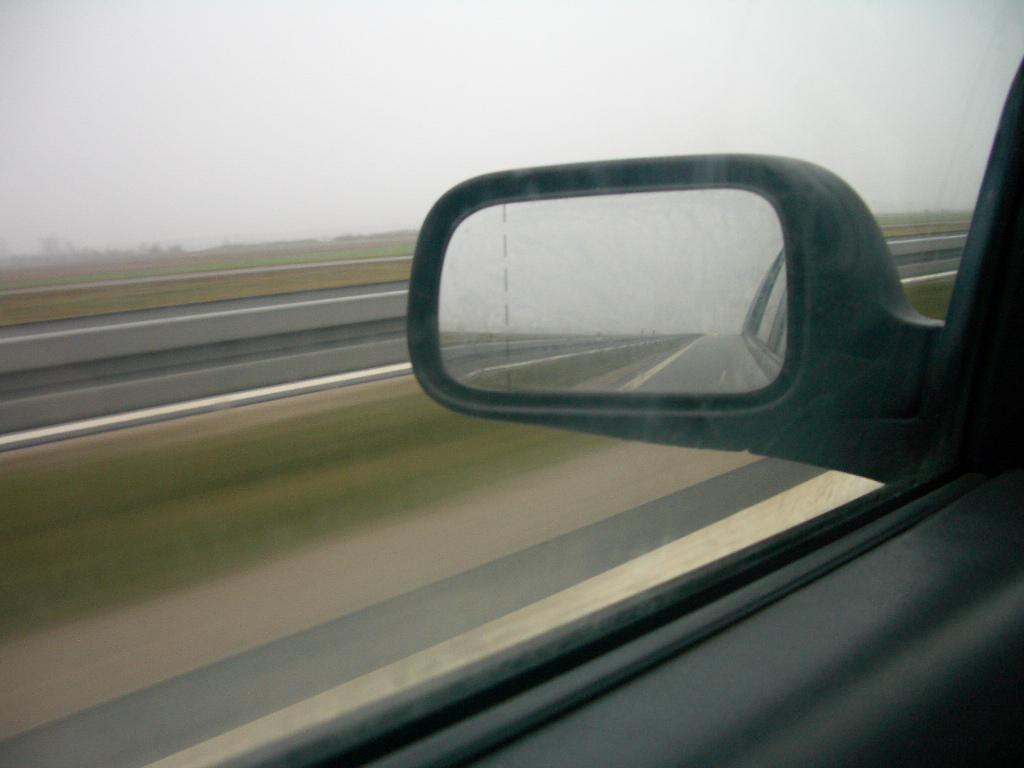What object is the main focus of the image? There is a car mirror in the image. Where was the image taken from? The image is taken from a car window. What can be seen behind the car window? There is a road visible behind the car window. What part of the natural environment is visible in the image? The sky is visible in the image. What type of celery is being used as a basketball in the image? There is no celery or basketball present in the image. How does the throat of the person in the car look in the image? There is no person or reference to a throat in the image; it only features a car mirror, a car window, a road, and the sky. 